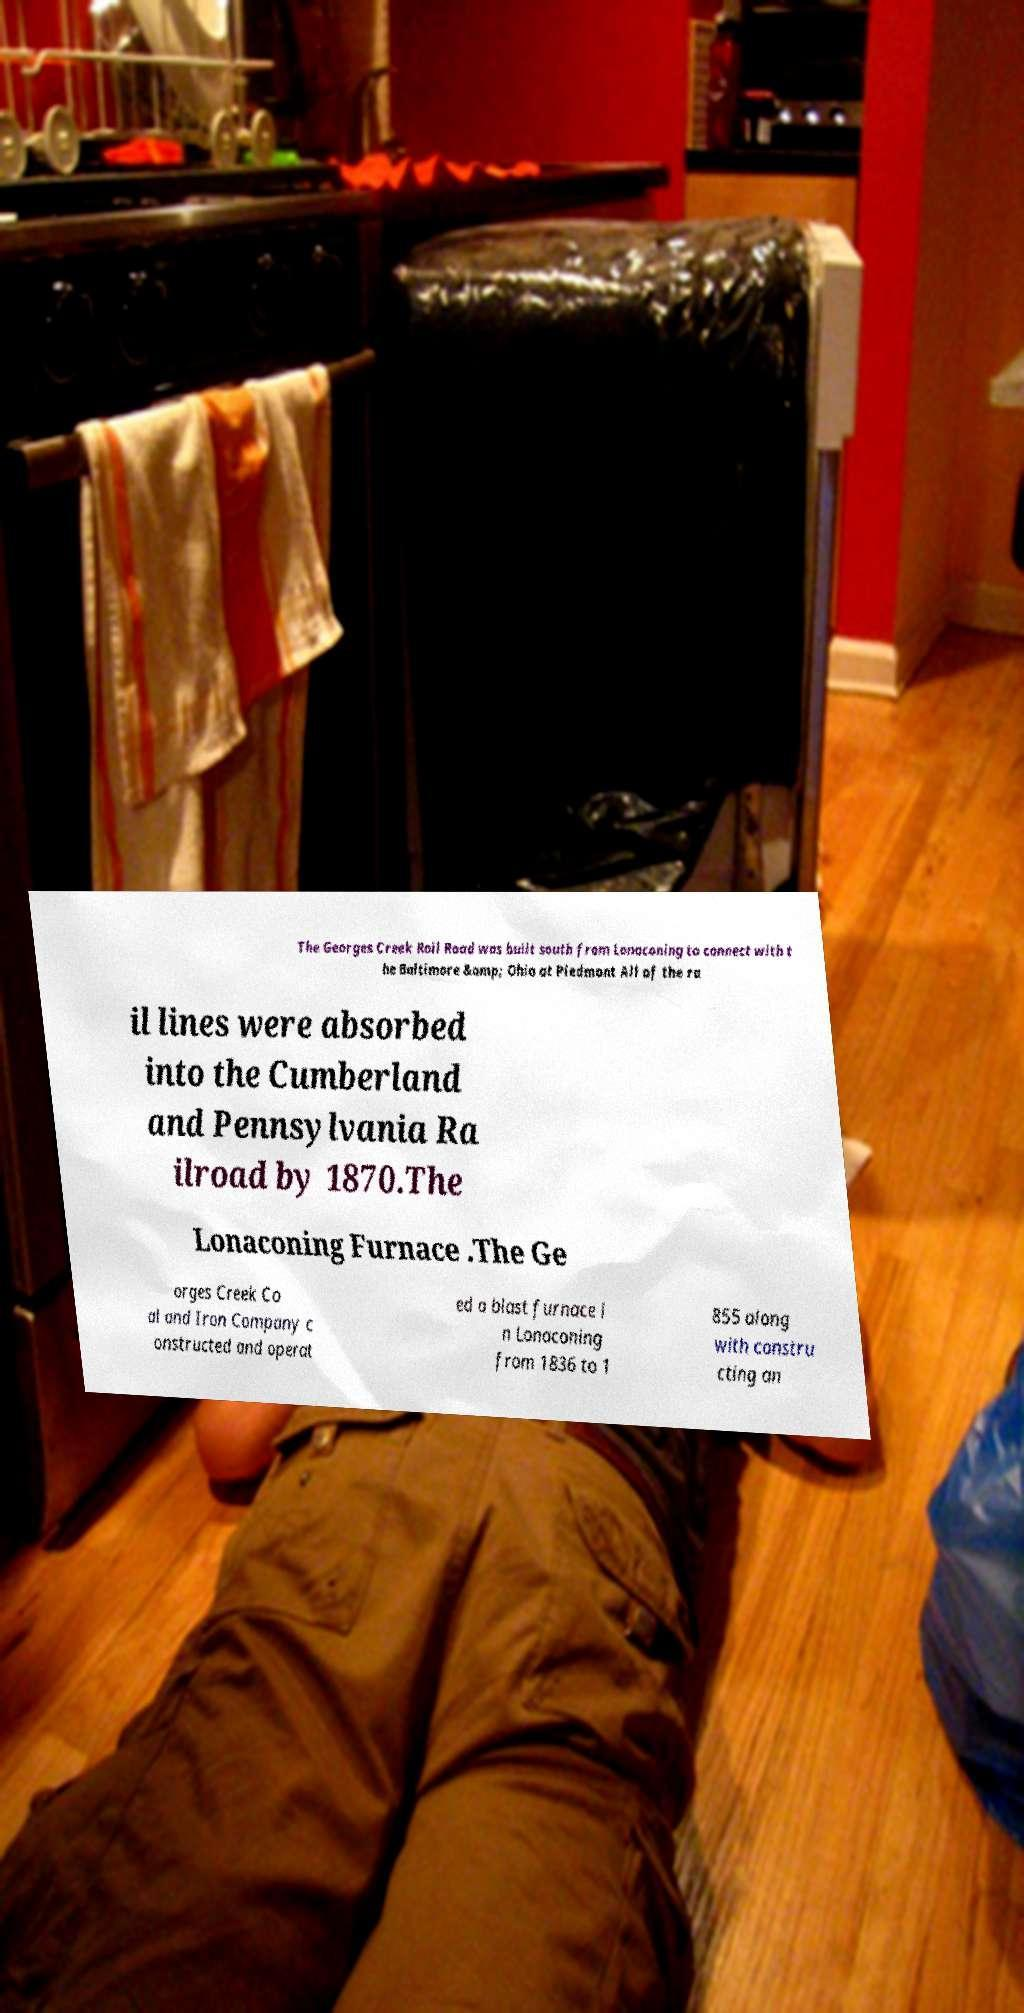I need the written content from this picture converted into text. Can you do that? The Georges Creek Rail Road was built south from Lonaconing to connect with t he Baltimore &amp; Ohio at Piedmont All of the ra il lines were absorbed into the Cumberland and Pennsylvania Ra ilroad by 1870.The Lonaconing Furnace .The Ge orges Creek Co al and Iron Company c onstructed and operat ed a blast furnace i n Lonaconing from 1836 to 1 855 along with constru cting an 